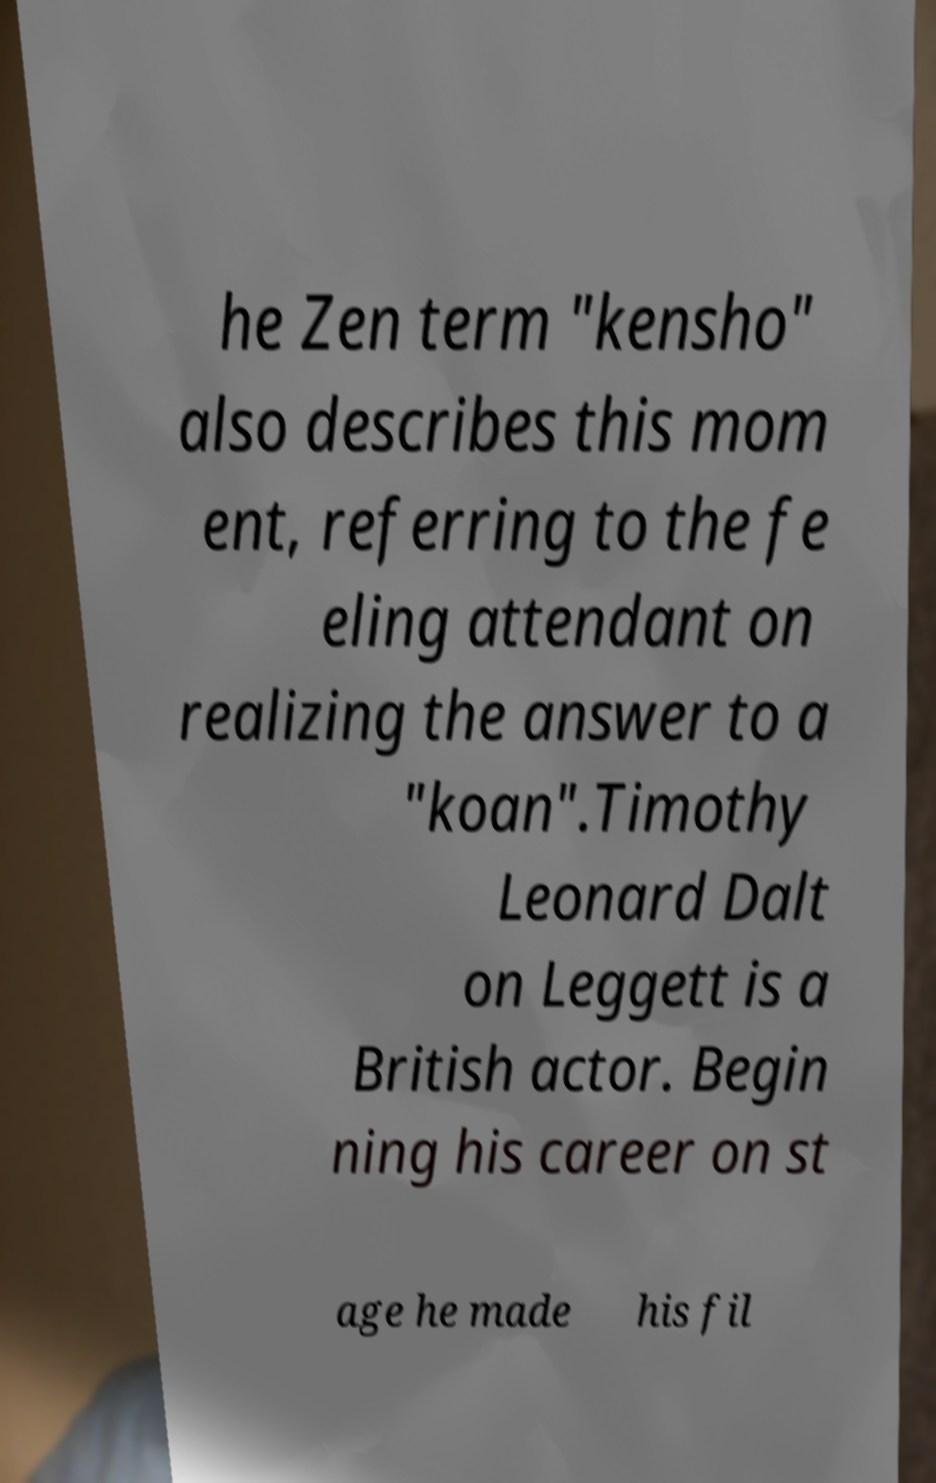What messages or text are displayed in this image? I need them in a readable, typed format. he Zen term "kensho" also describes this mom ent, referring to the fe eling attendant on realizing the answer to a "koan".Timothy Leonard Dalt on Leggett is a British actor. Begin ning his career on st age he made his fil 